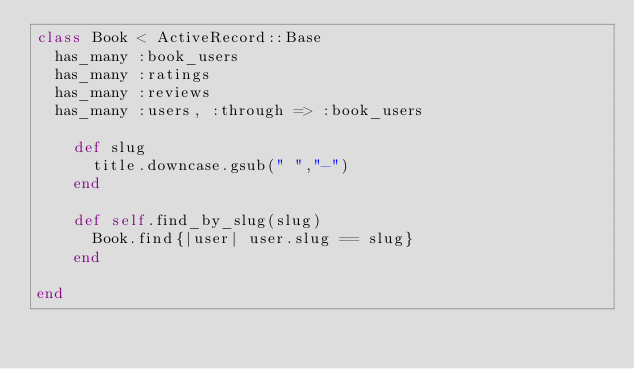<code> <loc_0><loc_0><loc_500><loc_500><_Ruby_>class Book < ActiveRecord::Base
  has_many :book_users
  has_many :ratings
  has_many :reviews
  has_many :users, :through => :book_users

    def slug
      title.downcase.gsub(" ","-")
    end

    def self.find_by_slug(slug)
      Book.find{|user| user.slug == slug}
    end

end
</code> 